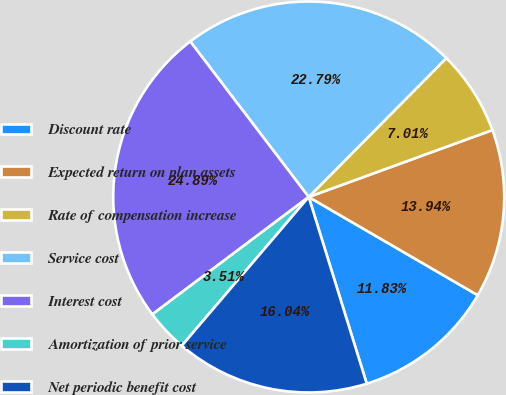<chart> <loc_0><loc_0><loc_500><loc_500><pie_chart><fcel>Discount rate<fcel>Expected return on plan assets<fcel>Rate of compensation increase<fcel>Service cost<fcel>Interest cost<fcel>Amortization of prior service<fcel>Net periodic benefit cost<nl><fcel>11.83%<fcel>13.94%<fcel>7.01%<fcel>22.79%<fcel>24.89%<fcel>3.51%<fcel>16.04%<nl></chart> 